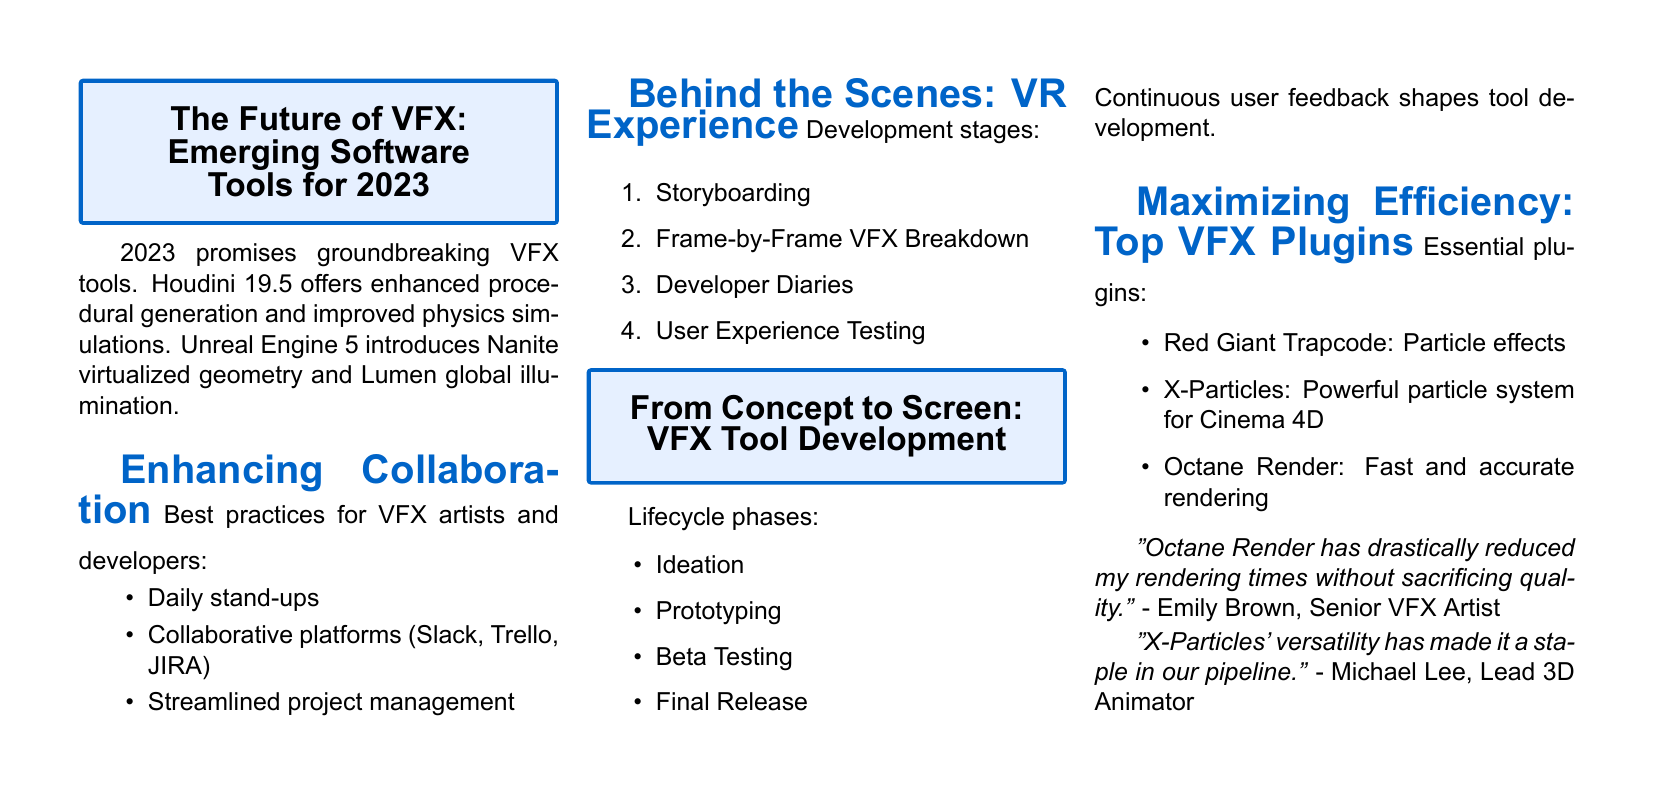What is the title of the first article? The title of the first article is presented at the top of the document, indicating the main focus on VFX software tools for 2023.
Answer: The Future of VFX: Emerging Software Tools for 2023 Which software tool version is mentioned for Houdini? The document directly states the version of Houdini that features enhanced capabilities, thus providing specific information.
Answer: 19.5 How many phases are there in the VFX tool development lifecycle? The document lists the lifecycle phases of VFX tool development, which can be counted for an accurate answer.
Answer: Four What is one recommended communication platform for VFX collaboration? The list of best practices for collaboration includes several platforms, providing specific examples of effective tools.
Answer: Slack Who is quoted regarding Octane Render? The document features a quote from a senior VFX artist, giving information about the contributor's identity in relation to the statement made.
Answer: Emily Brown Which particle effects plugin is mentioned first? The list of essential plugins starts with a specific plugin, providing a clear order of mention in the document.
Answer: Red Giant Trapcode How many items are there in the recommended plugins list? By counting the items listed under the essential plugins, we can derive the total number.
Answer: Three What is a key outcome of user feedback in VFX tool development? The document emphasizes the importance of user feedback, summarizing its influence over the tool's evolution.
Answer: Shapes tool development 